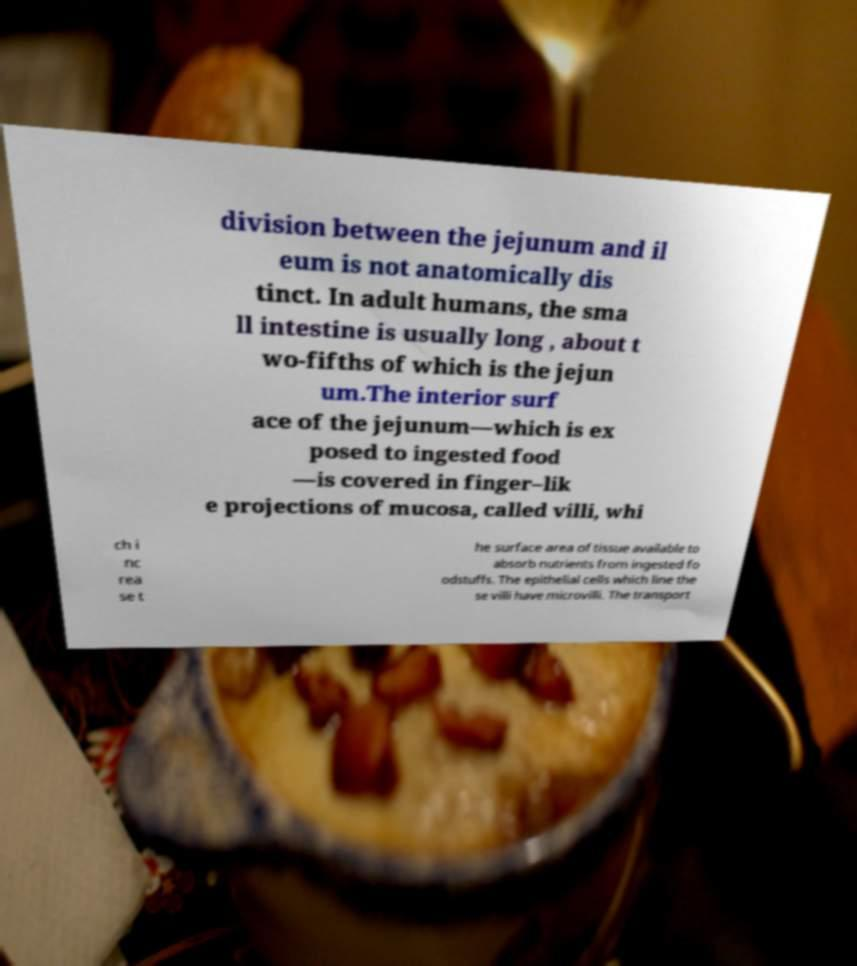Can you read and provide the text displayed in the image?This photo seems to have some interesting text. Can you extract and type it out for me? division between the jejunum and il eum is not anatomically dis tinct. In adult humans, the sma ll intestine is usually long , about t wo-fifths of which is the jejun um.The interior surf ace of the jejunum—which is ex posed to ingested food —is covered in finger–lik e projections of mucosa, called villi, whi ch i nc rea se t he surface area of tissue available to absorb nutrients from ingested fo odstuffs. The epithelial cells which line the se villi have microvilli. The transport 